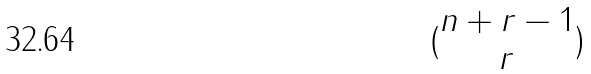<formula> <loc_0><loc_0><loc_500><loc_500>( \begin{matrix} n + r - 1 \\ r \end{matrix} )</formula> 